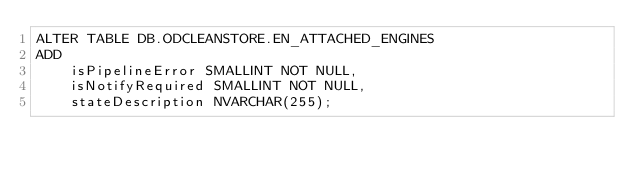<code> <loc_0><loc_0><loc_500><loc_500><_SQL_>ALTER TABLE DB.ODCLEANSTORE.EN_ATTACHED_ENGINES
ADD
	isPipelineError SMALLINT NOT NULL,
	isNotifyRequired SMALLINT NOT NULL,
	stateDescription NVARCHAR(255);

</code> 